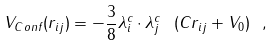Convert formula to latex. <formula><loc_0><loc_0><loc_500><loc_500>V _ { C o n f } ( r _ { i j } ) = - \frac { 3 } { 8 } \lambda ^ { c } _ { i } \cdot \lambda ^ { c } _ { j } \ ( C r _ { i j } + V _ { 0 } ) \ ,</formula> 